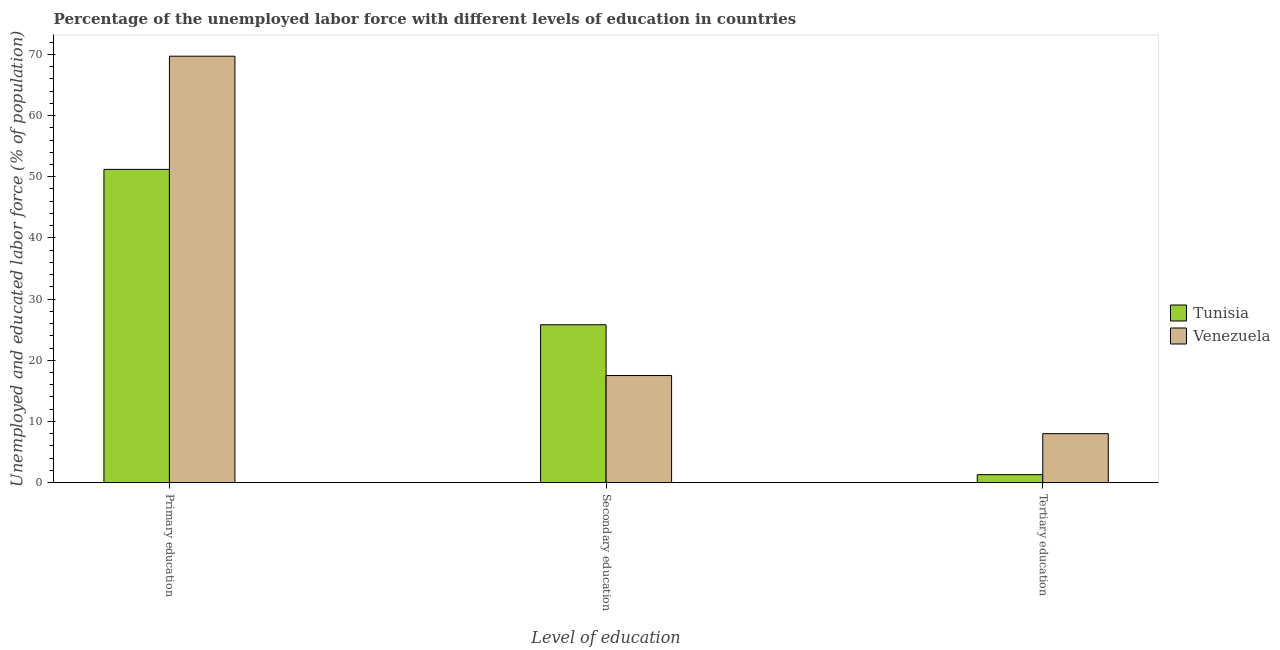What is the label of the 3rd group of bars from the left?
Provide a short and direct response. Tertiary education. What is the percentage of labor force who received tertiary education in Tunisia?
Keep it short and to the point. 1.3. Across all countries, what is the maximum percentage of labor force who received tertiary education?
Make the answer very short. 8. Across all countries, what is the minimum percentage of labor force who received tertiary education?
Your answer should be compact. 1.3. In which country was the percentage of labor force who received primary education maximum?
Make the answer very short. Venezuela. In which country was the percentage of labor force who received tertiary education minimum?
Ensure brevity in your answer.  Tunisia. What is the total percentage of labor force who received tertiary education in the graph?
Make the answer very short. 9.3. What is the difference between the percentage of labor force who received primary education in Venezuela and that in Tunisia?
Offer a terse response. 18.5. What is the difference between the percentage of labor force who received primary education in Tunisia and the percentage of labor force who received tertiary education in Venezuela?
Provide a short and direct response. 43.2. What is the average percentage of labor force who received primary education per country?
Keep it short and to the point. 60.45. What is the difference between the percentage of labor force who received tertiary education and percentage of labor force who received primary education in Venezuela?
Provide a succinct answer. -61.7. What is the ratio of the percentage of labor force who received primary education in Venezuela to that in Tunisia?
Offer a very short reply. 1.36. What is the difference between the highest and the second highest percentage of labor force who received primary education?
Your answer should be very brief. 18.5. What is the difference between the highest and the lowest percentage of labor force who received primary education?
Ensure brevity in your answer.  18.5. In how many countries, is the percentage of labor force who received tertiary education greater than the average percentage of labor force who received tertiary education taken over all countries?
Your response must be concise. 1. What does the 1st bar from the left in Tertiary education represents?
Ensure brevity in your answer.  Tunisia. What does the 1st bar from the right in Primary education represents?
Your answer should be very brief. Venezuela. Are all the bars in the graph horizontal?
Make the answer very short. No. How many countries are there in the graph?
Offer a terse response. 2. Are the values on the major ticks of Y-axis written in scientific E-notation?
Offer a terse response. No. Does the graph contain any zero values?
Keep it short and to the point. No. What is the title of the graph?
Your response must be concise. Percentage of the unemployed labor force with different levels of education in countries. What is the label or title of the X-axis?
Make the answer very short. Level of education. What is the label or title of the Y-axis?
Provide a succinct answer. Unemployed and educated labor force (% of population). What is the Unemployed and educated labor force (% of population) in Tunisia in Primary education?
Offer a terse response. 51.2. What is the Unemployed and educated labor force (% of population) of Venezuela in Primary education?
Ensure brevity in your answer.  69.7. What is the Unemployed and educated labor force (% of population) of Tunisia in Secondary education?
Your answer should be compact. 25.8. What is the Unemployed and educated labor force (% of population) in Tunisia in Tertiary education?
Make the answer very short. 1.3. Across all Level of education, what is the maximum Unemployed and educated labor force (% of population) in Tunisia?
Provide a short and direct response. 51.2. Across all Level of education, what is the maximum Unemployed and educated labor force (% of population) in Venezuela?
Make the answer very short. 69.7. Across all Level of education, what is the minimum Unemployed and educated labor force (% of population) of Tunisia?
Offer a terse response. 1.3. What is the total Unemployed and educated labor force (% of population) in Tunisia in the graph?
Your answer should be compact. 78.3. What is the total Unemployed and educated labor force (% of population) in Venezuela in the graph?
Your answer should be compact. 95.2. What is the difference between the Unemployed and educated labor force (% of population) in Tunisia in Primary education and that in Secondary education?
Keep it short and to the point. 25.4. What is the difference between the Unemployed and educated labor force (% of population) of Venezuela in Primary education and that in Secondary education?
Offer a terse response. 52.2. What is the difference between the Unemployed and educated labor force (% of population) of Tunisia in Primary education and that in Tertiary education?
Your response must be concise. 49.9. What is the difference between the Unemployed and educated labor force (% of population) in Venezuela in Primary education and that in Tertiary education?
Give a very brief answer. 61.7. What is the difference between the Unemployed and educated labor force (% of population) in Tunisia in Secondary education and that in Tertiary education?
Keep it short and to the point. 24.5. What is the difference between the Unemployed and educated labor force (% of population) in Tunisia in Primary education and the Unemployed and educated labor force (% of population) in Venezuela in Secondary education?
Provide a short and direct response. 33.7. What is the difference between the Unemployed and educated labor force (% of population) in Tunisia in Primary education and the Unemployed and educated labor force (% of population) in Venezuela in Tertiary education?
Keep it short and to the point. 43.2. What is the difference between the Unemployed and educated labor force (% of population) of Tunisia in Secondary education and the Unemployed and educated labor force (% of population) of Venezuela in Tertiary education?
Your response must be concise. 17.8. What is the average Unemployed and educated labor force (% of population) of Tunisia per Level of education?
Give a very brief answer. 26.1. What is the average Unemployed and educated labor force (% of population) in Venezuela per Level of education?
Offer a terse response. 31.73. What is the difference between the Unemployed and educated labor force (% of population) of Tunisia and Unemployed and educated labor force (% of population) of Venezuela in Primary education?
Your answer should be very brief. -18.5. What is the difference between the Unemployed and educated labor force (% of population) of Tunisia and Unemployed and educated labor force (% of population) of Venezuela in Secondary education?
Make the answer very short. 8.3. What is the ratio of the Unemployed and educated labor force (% of population) in Tunisia in Primary education to that in Secondary education?
Offer a very short reply. 1.98. What is the ratio of the Unemployed and educated labor force (% of population) of Venezuela in Primary education to that in Secondary education?
Offer a very short reply. 3.98. What is the ratio of the Unemployed and educated labor force (% of population) of Tunisia in Primary education to that in Tertiary education?
Offer a very short reply. 39.38. What is the ratio of the Unemployed and educated labor force (% of population) in Venezuela in Primary education to that in Tertiary education?
Your answer should be very brief. 8.71. What is the ratio of the Unemployed and educated labor force (% of population) in Tunisia in Secondary education to that in Tertiary education?
Your response must be concise. 19.85. What is the ratio of the Unemployed and educated labor force (% of population) in Venezuela in Secondary education to that in Tertiary education?
Your answer should be compact. 2.19. What is the difference between the highest and the second highest Unemployed and educated labor force (% of population) in Tunisia?
Offer a terse response. 25.4. What is the difference between the highest and the second highest Unemployed and educated labor force (% of population) of Venezuela?
Keep it short and to the point. 52.2. What is the difference between the highest and the lowest Unemployed and educated labor force (% of population) in Tunisia?
Provide a short and direct response. 49.9. What is the difference between the highest and the lowest Unemployed and educated labor force (% of population) in Venezuela?
Provide a succinct answer. 61.7. 